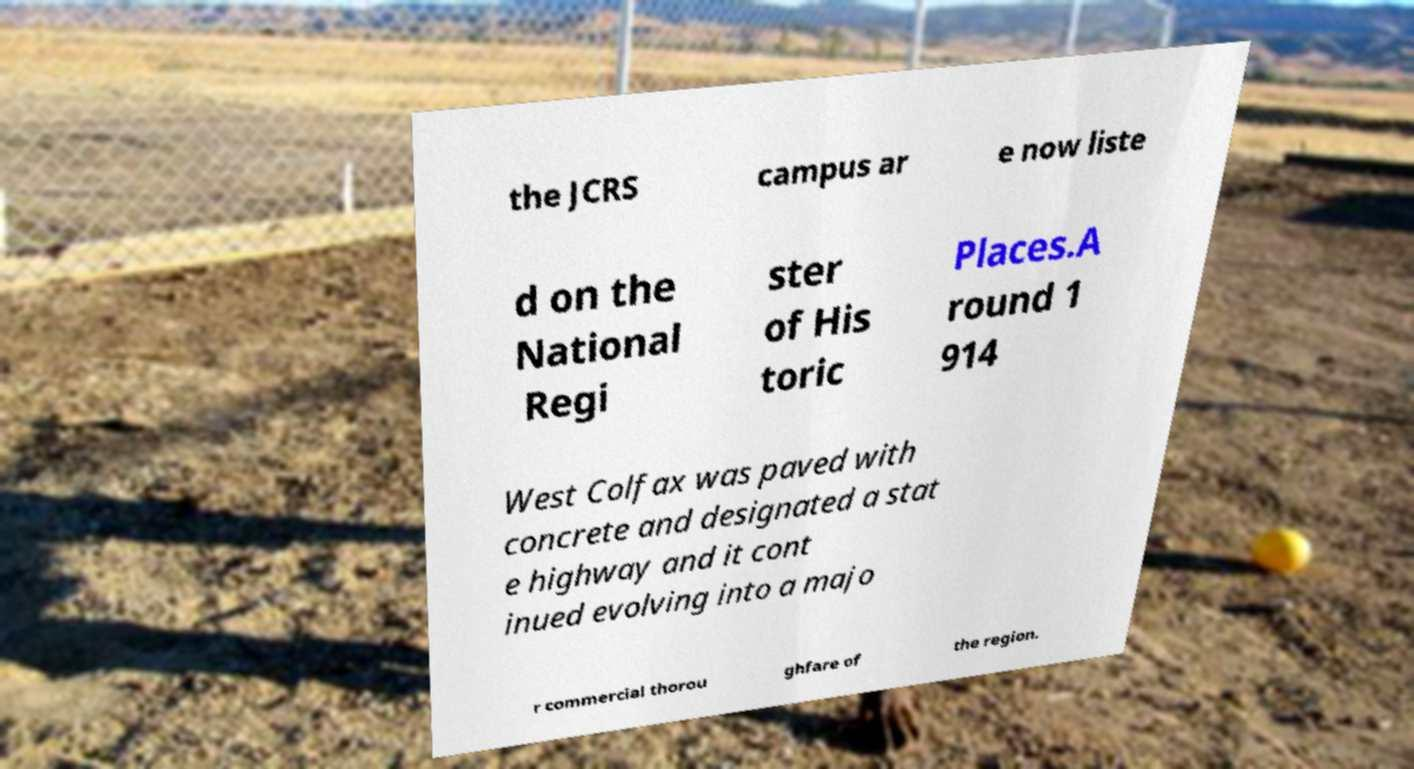What messages or text are displayed in this image? I need them in a readable, typed format. the JCRS campus ar e now liste d on the National Regi ster of His toric Places.A round 1 914 West Colfax was paved with concrete and designated a stat e highway and it cont inued evolving into a majo r commercial thorou ghfare of the region. 